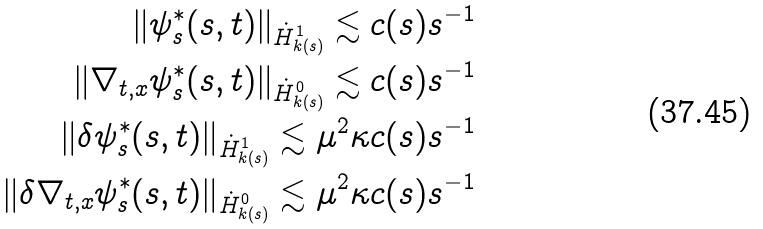<formula> <loc_0><loc_0><loc_500><loc_500>\| \psi ^ { * } _ { s } ( s , t ) \| _ { \dot { H } ^ { 1 } _ { k ( s ) } } \lesssim c ( s ) s ^ { - 1 } \\ \| \nabla _ { t , x } \psi ^ { * } _ { s } ( s , t ) \| _ { \dot { H } ^ { 0 } _ { k ( s ) } } \lesssim c ( s ) s ^ { - 1 } \\ \| \delta \psi ^ { * } _ { s } ( s , t ) \| _ { \dot { H } ^ { 1 } _ { k ( s ) } } \lesssim \mu ^ { 2 } \kappa c ( s ) s ^ { - 1 } \\ \| \delta \nabla _ { t , x } \psi ^ { * } _ { s } ( s , t ) \| _ { \dot { H } ^ { 0 } _ { k ( s ) } } \lesssim \mu ^ { 2 } \kappa c ( s ) s ^ { - 1 }</formula> 